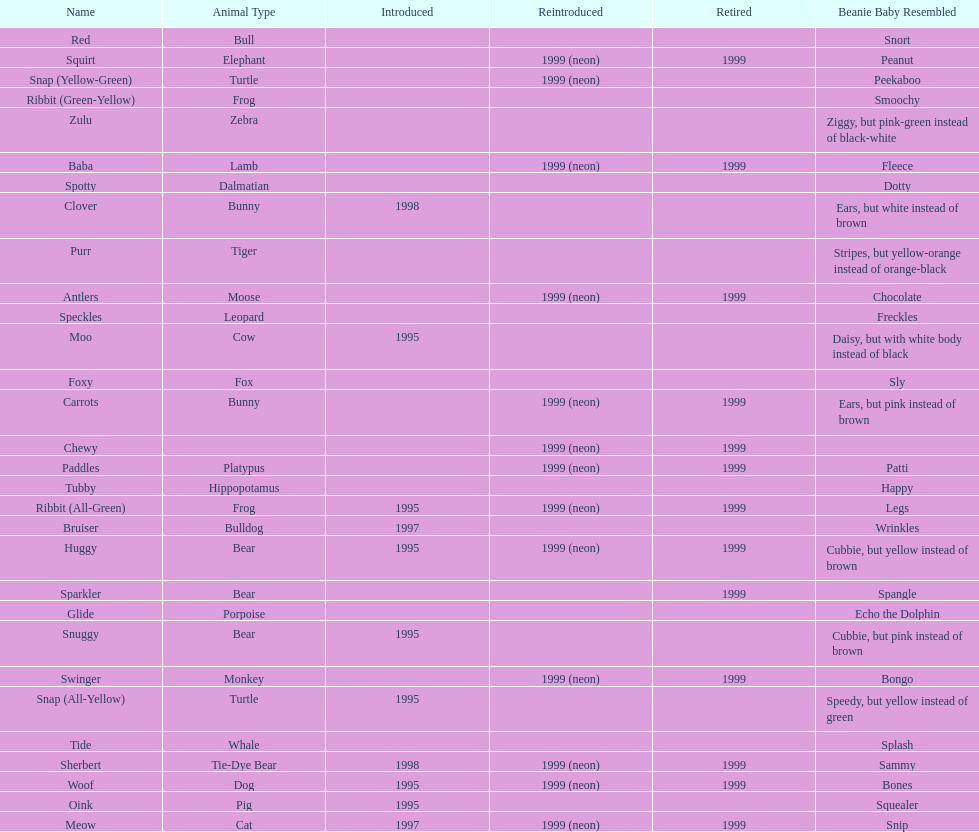What is the total number of pillow pals that were reintroduced as a neon variety? 13. 